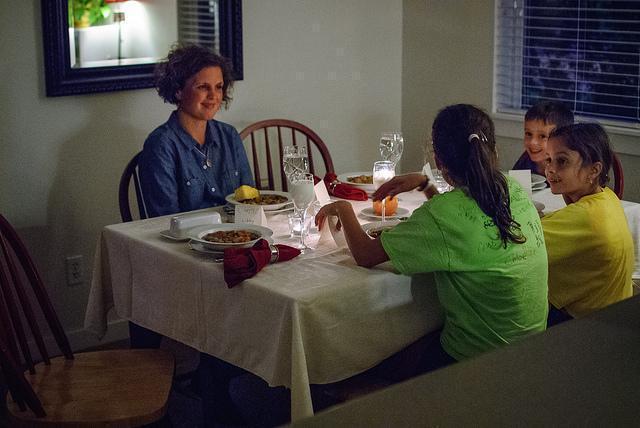What is holding the red napkin together?
Select the accurate answer and provide explanation: 'Answer: answer
Rationale: rationale.'
Options: Napkin ring, friction, bracelet, tape. Answer: napkin ring.
Rationale: There is a silver circle encompassing the red material to keep its shape. 